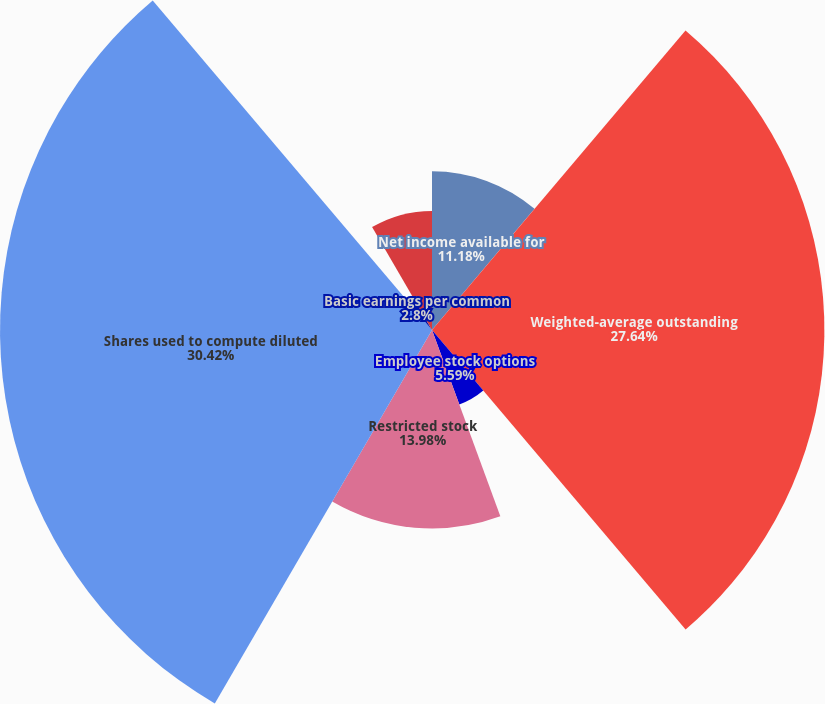Convert chart to OTSL. <chart><loc_0><loc_0><loc_500><loc_500><pie_chart><fcel>Net income available for<fcel>Weighted-average outstanding<fcel>Employee stock options<fcel>Restricted stock<fcel>Shares used to compute diluted<fcel>Basic earnings per common<fcel>Diluted earnings per common<fcel>Number of antidilutive stock<nl><fcel>11.18%<fcel>27.64%<fcel>5.59%<fcel>13.98%<fcel>30.43%<fcel>2.8%<fcel>0.0%<fcel>8.39%<nl></chart> 